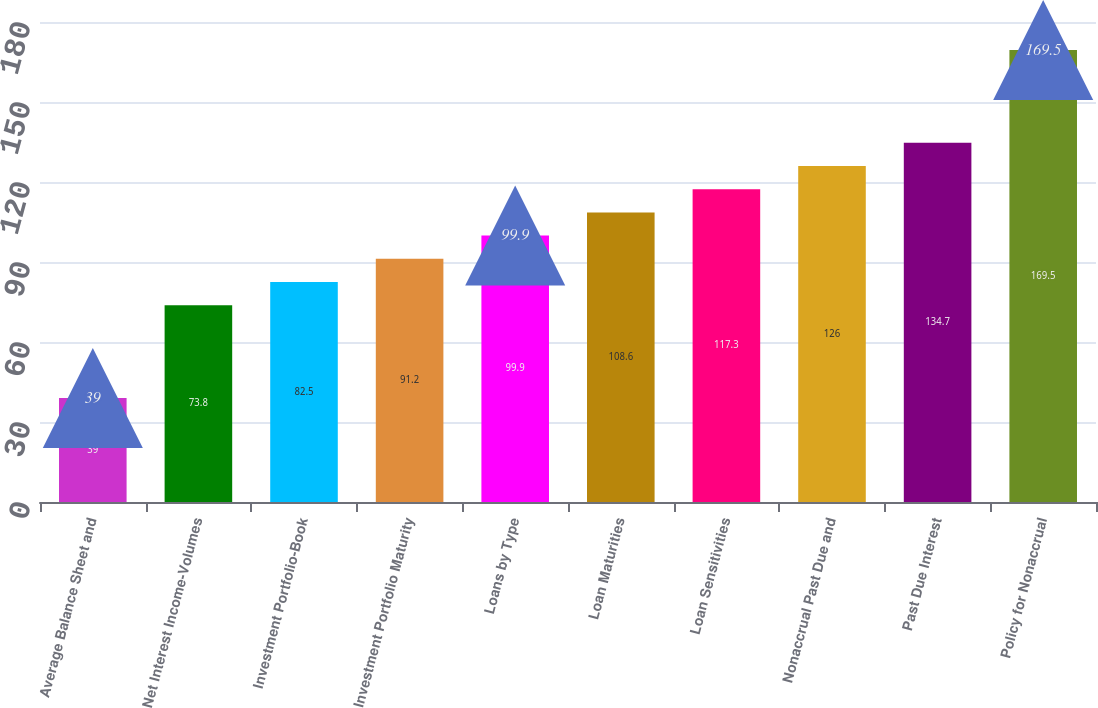<chart> <loc_0><loc_0><loc_500><loc_500><bar_chart><fcel>Average Balance Sheet and<fcel>Net Interest Income-Volumes<fcel>Investment Portfolio-Book<fcel>Investment Portfolio Maturity<fcel>Loans by Type<fcel>Loan Maturities<fcel>Loan Sensitivities<fcel>Nonaccrual Past Due and<fcel>Past Due Interest<fcel>Policy for Nonaccrual<nl><fcel>39<fcel>73.8<fcel>82.5<fcel>91.2<fcel>99.9<fcel>108.6<fcel>117.3<fcel>126<fcel>134.7<fcel>169.5<nl></chart> 